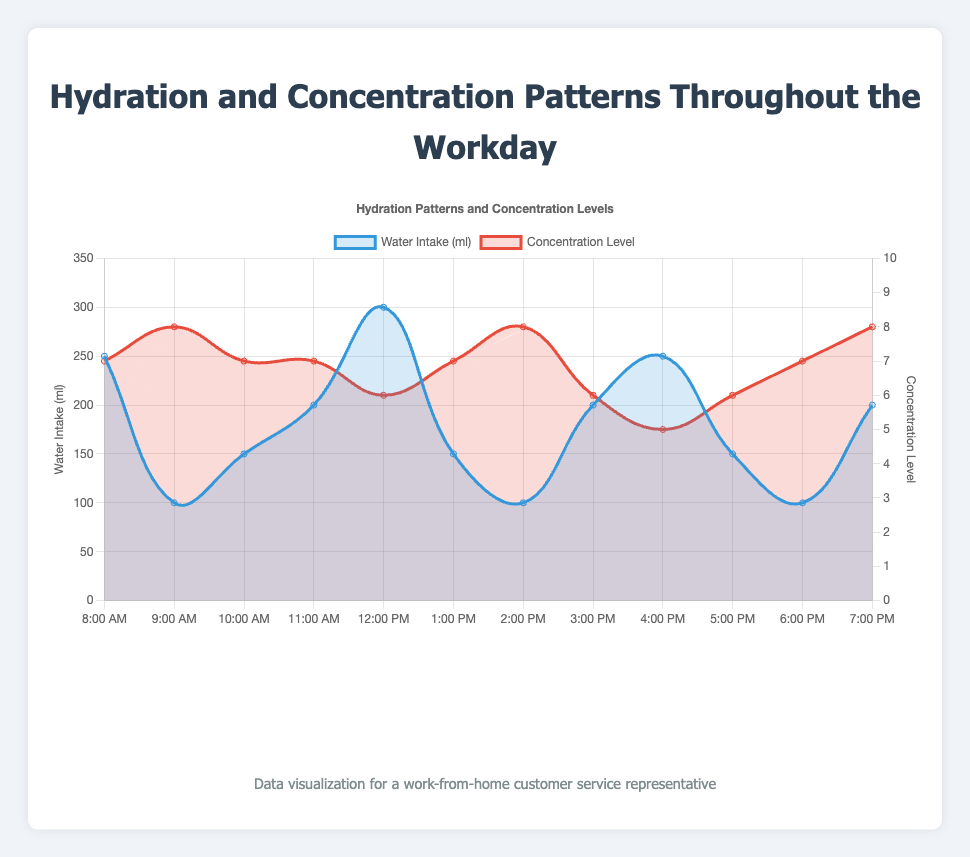what time of day has the highest concentration level? According to the figure, the highest concentration level of 8 can be seen at both 9:00 AM, 2:00 PM, and 7:00 PM.
Answer: 9:00 AM, 2:00 PM, 7:00 PM how does water intake relate to concentration level at noon? At 12:00 PM, the water intake is 300 ml, and the concentration level is 6. The concentration level doesn't seem to peak despite the increased water intake.
Answer: At 12:00 PM: 300 ml water, concentration level 6 what is the total water intake from 8:00 AM to 12:00 PM? Summing the water intake from 8:00 AM to 12:00 PM: 250 ml at 8:00 AM, 100 ml at 9:00 AM, 150 ml at 10:00 AM, 200 ml at 11:00 AM, and 300 ml at 12:00 PM. Total: 250+100+150+200+300 = 1000 ml.
Answer: 1000 ml what is the average concentration level between 3:00 PM and 5:00 PM? The concentration levels at 3:00 PM, 4:00 PM, and 5:00 PM are 6, 5, and 6 respectively. Average: (6+5+6) / 3 = 17/3 ≈ 5.67.
Answer: 5.67 compare the concentration levels at 2:00 PM and 3:00 PM. which is higher? At 2:00 PM, the concentration level is 8, while at 3:00 PM, it is 6. Therefore, the concentration level at 2:00 PM is higher.
Answer: 2:00 PM is there a noticeable trend between the water intake and concentration levels after 5:00 PM? After 5:00 PM, water intake remains low compared to other times, and concentration levels fluctuate with a level of 7 at 6:00 PM and 8 at 7:00 PM. There is no clear positive correlation.
Answer: fluctuating what is the difference in concentration levels between 9:00 AM and 4:00 PM? The concentration level at 9:00 AM is 8 and at 4:00 PM is 5. The difference is 8 - 5 = 3.
Answer: 3 observe the water intake pattern at 2:00 PM and 3:00 PM. how are they similar or different? At 2:00 PM, the water intake is 100 ml, and at 3:00 PM, it is 200 ml. The intake at 3:00 PM is double that of 2:00 PM.
Answer: double when does concentration level drop to its lowest in the workday? The lowest concentration level of 5 is observed at 4:00 PM according to the figure.
Answer: 4:00 PM how does water intake at 7:00 PM compare to the intake at 8:00 AM? At 7:00 PM, water intake is 200 ml, which is 50 ml less than the 250 ml intake at 8:00 AM.
Answer: 50 ml less 